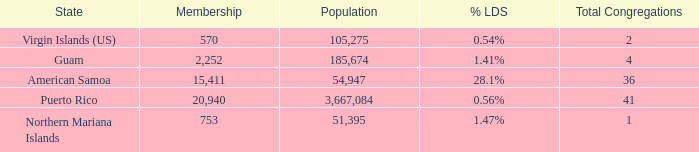What is Population, when Total Congregations is less than 4, and when % LDS is 0.54%? 105275.0. 